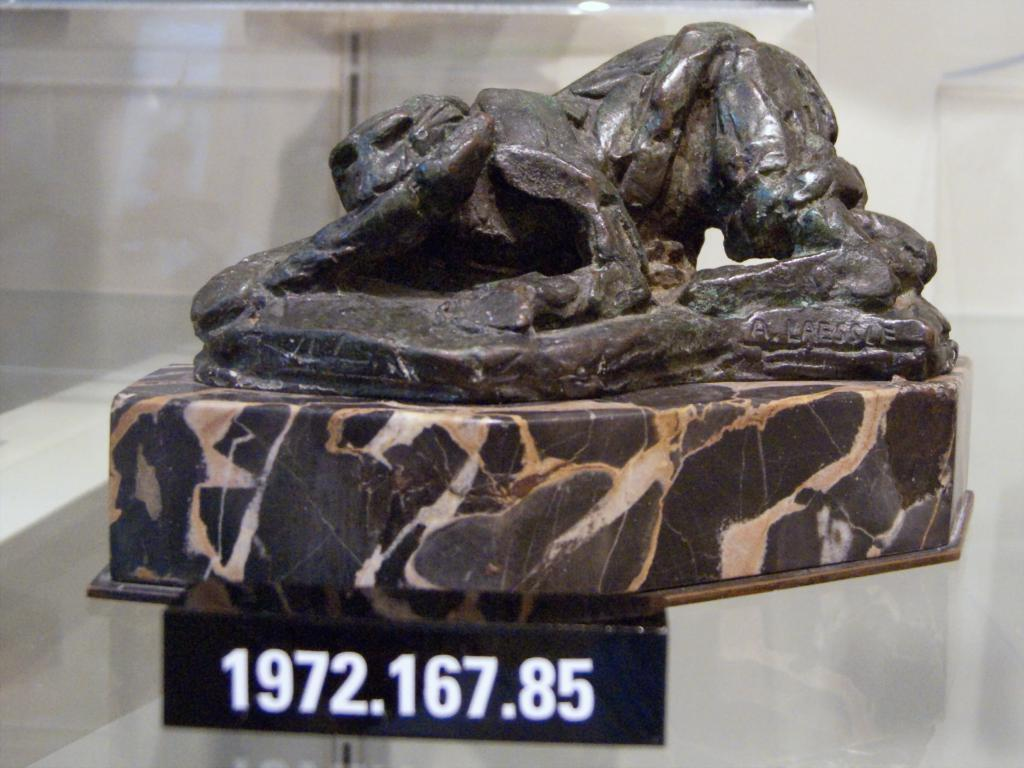What is the main subject of the image? The main subject of the image is a sculpture on a stone. What else can be seen in the image? There is a board in the image. What is written or displayed on the board? The board has numbers on it. Can you tell me how many frogs are sitting on the sculpture in the image? There are no frogs present in the image; the sculpture is the main subject. What type of representative is standing next to the board in the image? There is no representative present in the image; the board has numbers on it, but no people are visible. 